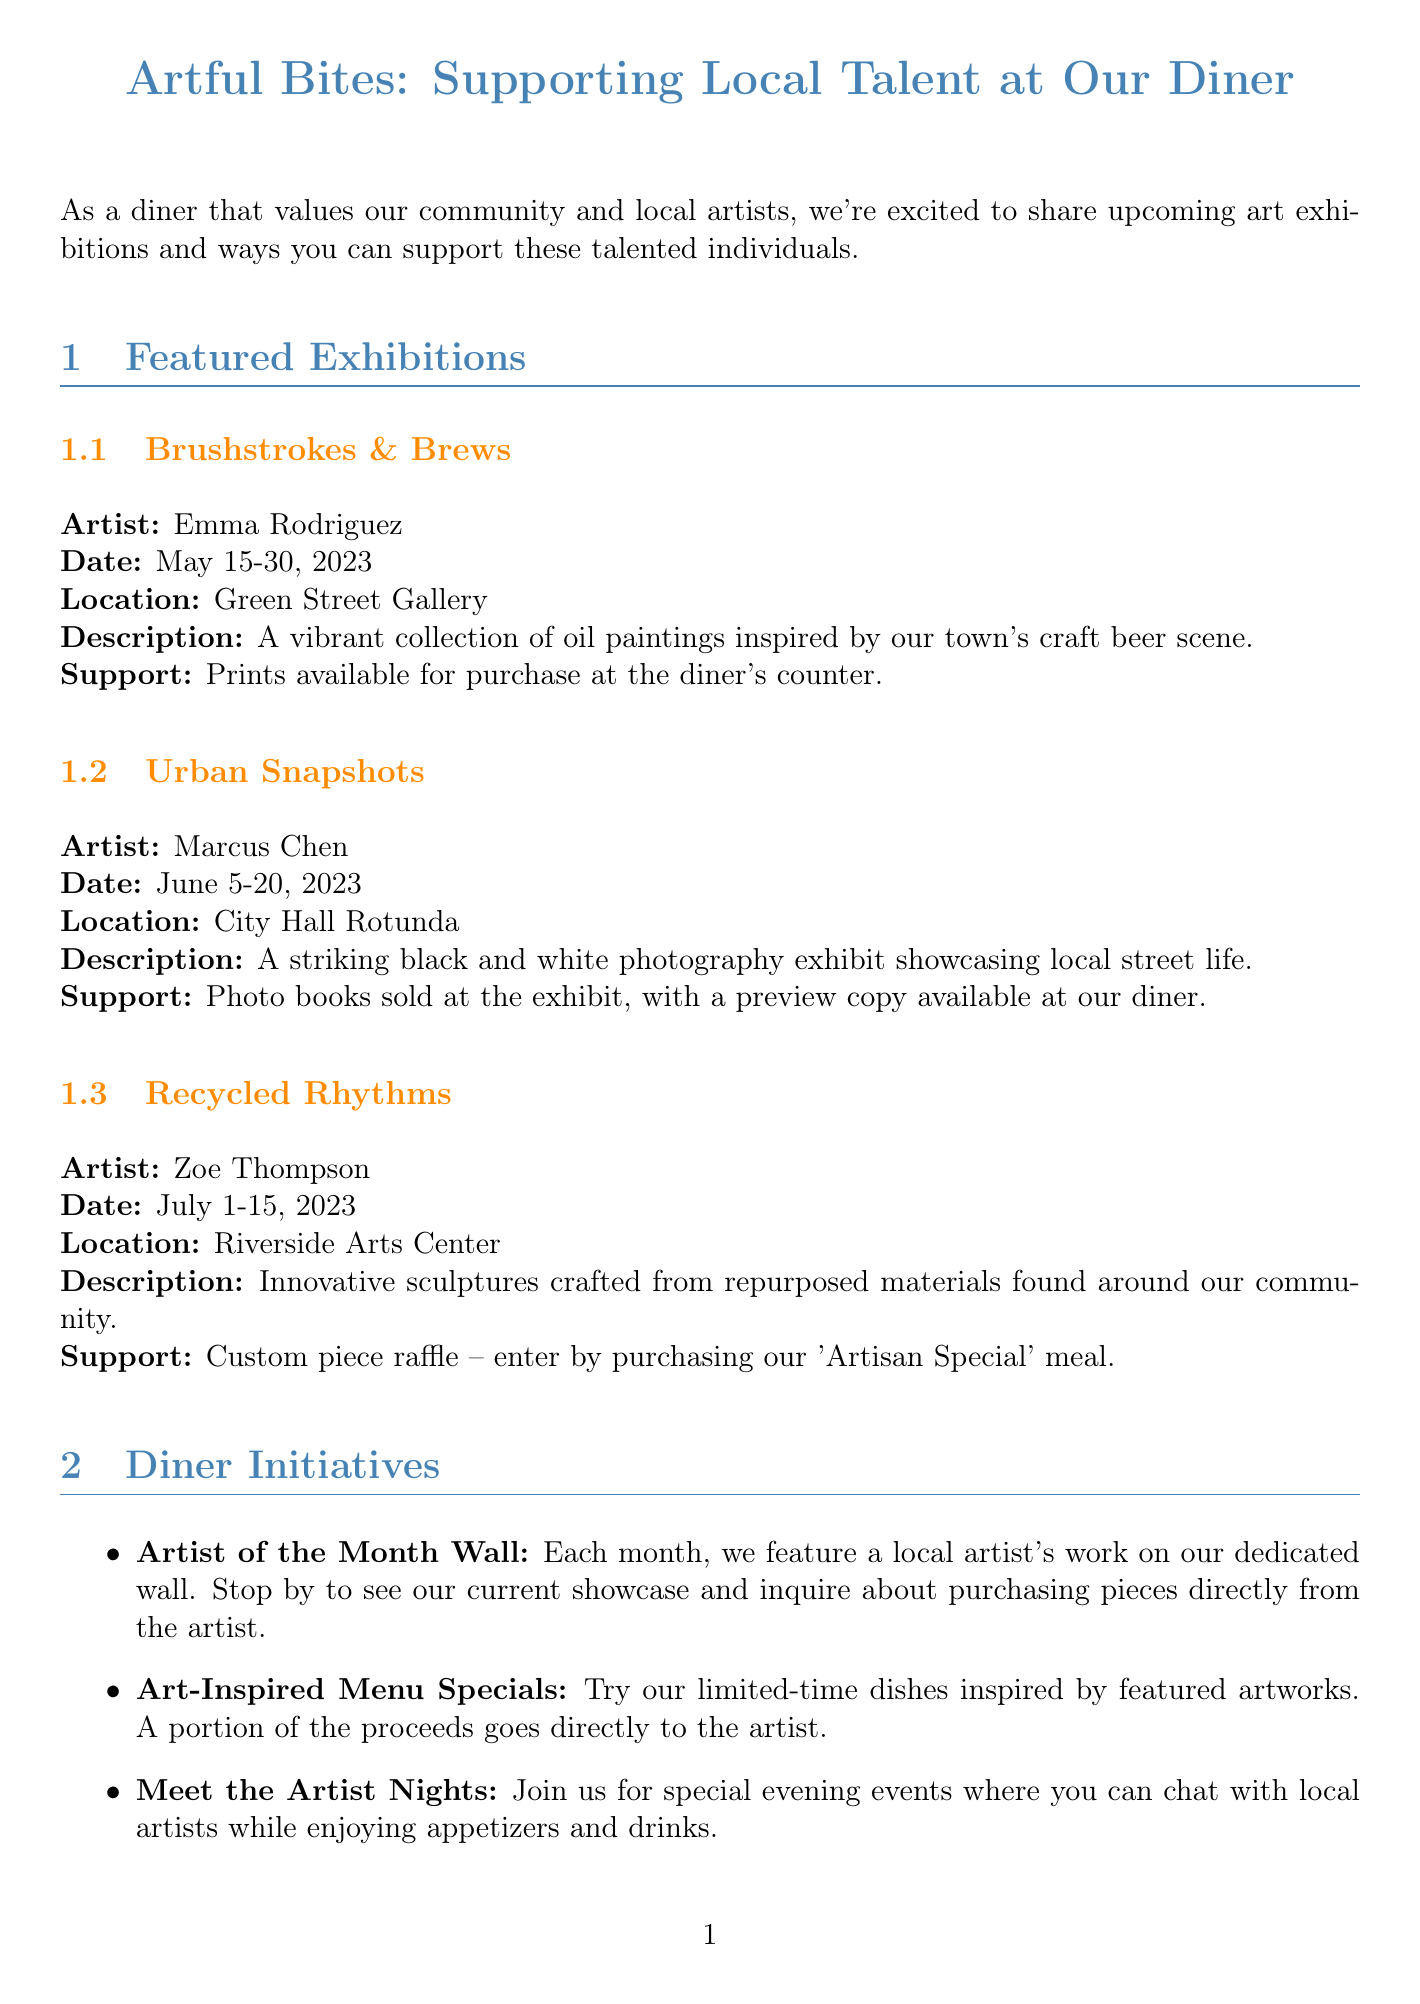What is the title of the newsletter? The title is stated at the beginning of the document.
Answer: Artful Bites: Supporting Local Talent at Our Diner Who is the artist for the exhibition "Urban Snapshots"? The artist's name is specified in the details of the exhibition.
Answer: Marcus Chen When is the exhibition "Recycled Rhythms" scheduled? The dates are provided for this particular exhibition in the document.
Answer: July 1-15, 2023 What unique gift option is available for the exhibition "Brushstrokes & Brews"? The support option specifies how customers can contribute during this exhibition.
Answer: Prints available for purchase at the diner's counter Which diner initiative allows direct interaction with artists? The document highlights different initiatives, one of which focuses on meeting artists.
Answer: Meet the Artist Nights What kind of art can we expect from "Recycled Rhythms"? The description provides insight into the type of artwork featured in this exhibition.
Answer: Innovative sculptures crafted from repurposed materials How can customers support local artists according to the community support ideas? The document lists various ways to support local artists within the community.
Answer: Attend exhibition openings to show your support and meet the artists What date does the exhibition "Brushstrokes & Brews" begin? The starting date of the exhibition is clearly mentioned in the details.
Answer: May 15, 2023 